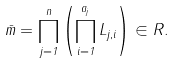<formula> <loc_0><loc_0><loc_500><loc_500>\bar { m } = \prod _ { j = 1 } ^ { n } \left ( \prod _ { i = 1 } ^ { a _ { j } } L _ { j , i } \right ) \in R .</formula> 